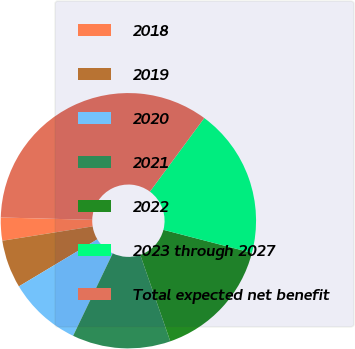Convert chart to OTSL. <chart><loc_0><loc_0><loc_500><loc_500><pie_chart><fcel>2018<fcel>2019<fcel>2020<fcel>2021<fcel>2022<fcel>2023 through 2027<fcel>Total expected net benefit<nl><fcel>2.91%<fcel>6.09%<fcel>9.27%<fcel>12.45%<fcel>15.63%<fcel>18.92%<fcel>34.72%<nl></chart> 